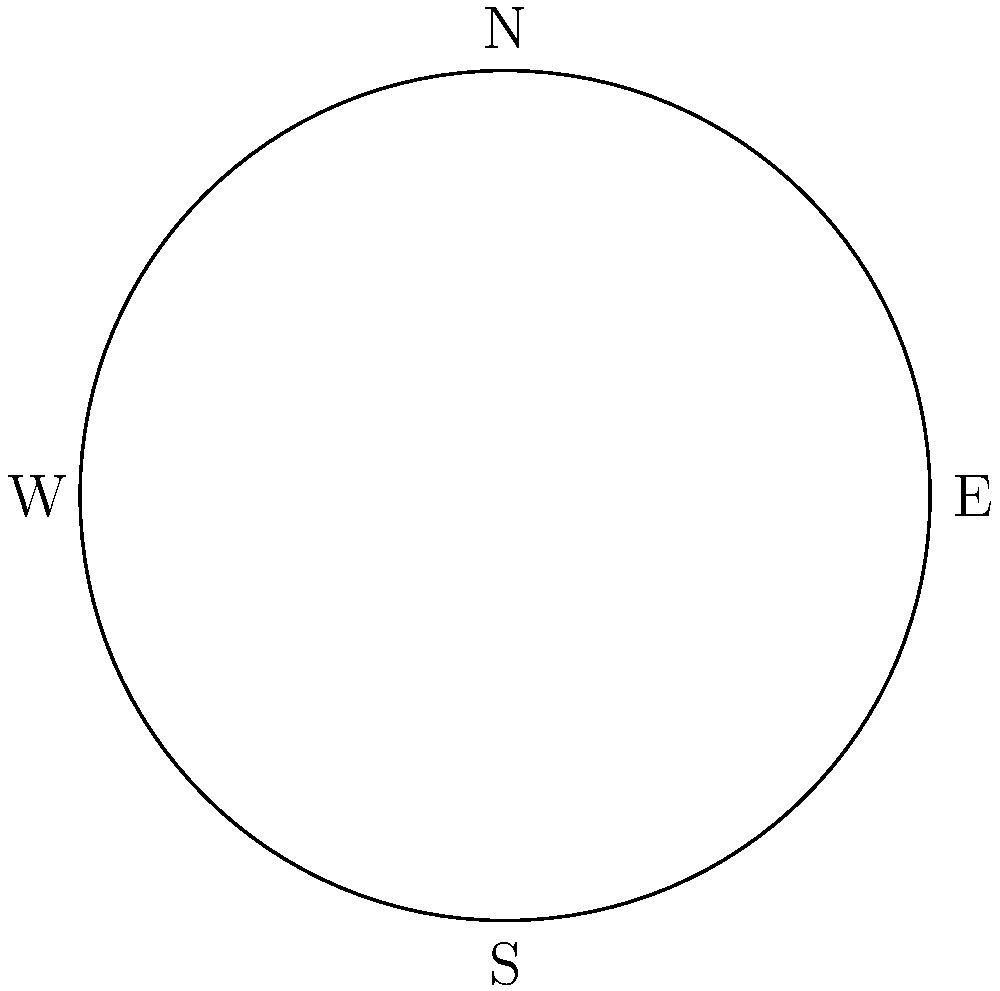Which constellation is always visible from Valencia (latitude 39.5°N) and appears to rotate around Polaris? To answer this question, let's consider the following steps:

1. Valencia's latitude is 39.5°N, which means it's in the Northern Hemisphere.

2. The altitude of Polaris (the North Star) above the horizon is approximately equal to the observer's latitude. In this case, it's about 39.5° above the northern horizon.

3. Constellations that are closer to Polaris than this angle will never set below the horizon from Valencia's perspective. These are called circumpolar constellations.

4. The constellation Ursa Minor (Little Bear) contains Polaris as its brightest star and is entirely within 39.5° of Polaris.

5. Other circumpolar constellations visible from Valencia include Ursa Major (Great Bear), Cassiopeia, Cepheus, and Draco. However, Ursa Minor is the closest to Polaris and entirely visible.

6. Ursa Minor appears to rotate around Polaris as the Earth rotates, making a complete circle in the sky every 24 hours.

Therefore, the constellation that is always visible from Valencia and appears to rotate around Polaris is Ursa Minor.
Answer: Ursa Minor 